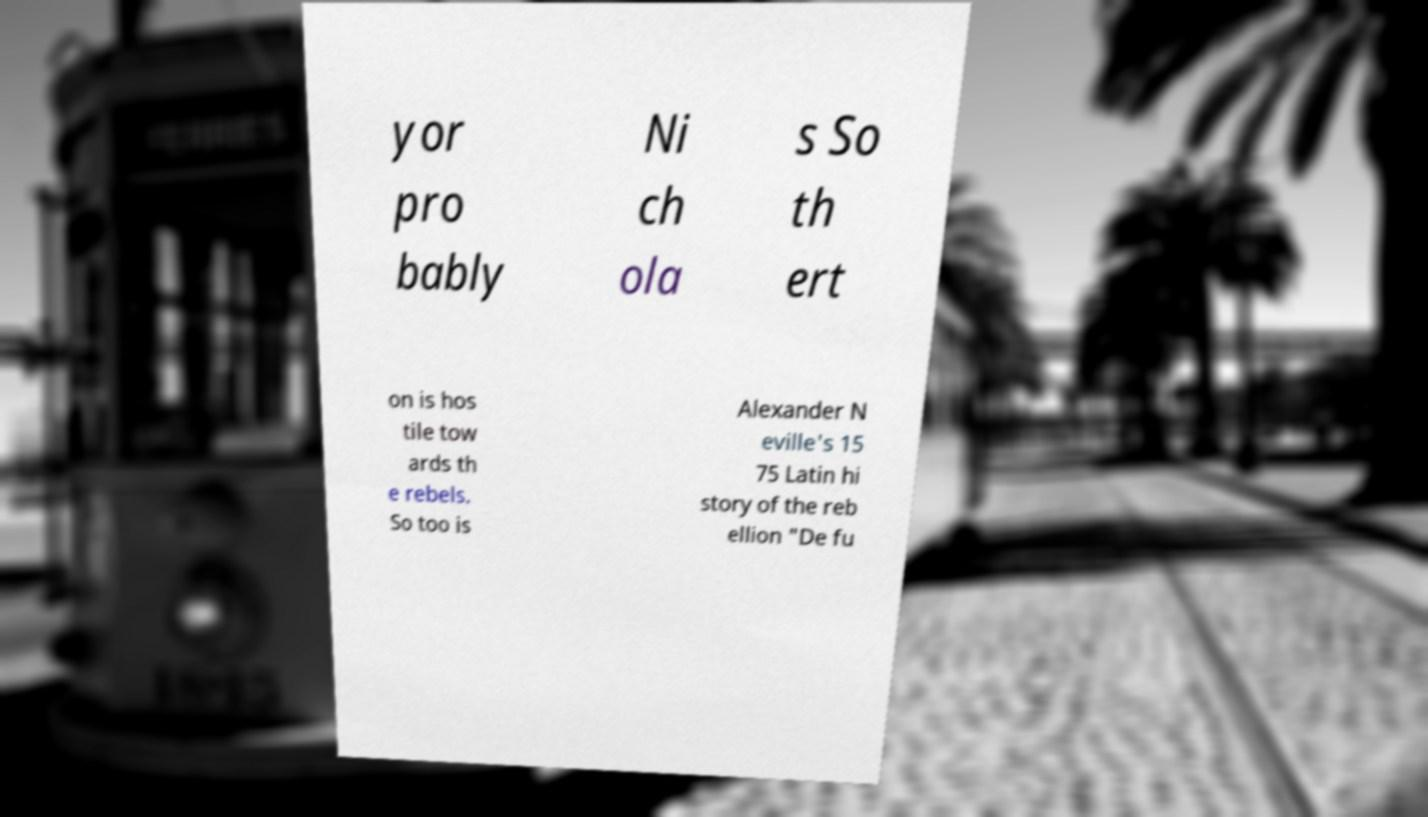Could you assist in decoding the text presented in this image and type it out clearly? yor pro bably Ni ch ola s So th ert on is hos tile tow ards th e rebels. So too is Alexander N eville's 15 75 Latin hi story of the reb ellion "De fu 